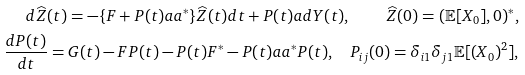<formula> <loc_0><loc_0><loc_500><loc_500>d \widehat { Z } ( t ) = - \{ F + P ( t ) a a ^ { * } \} \widehat { Z } ( t ) d t + P ( t ) a d Y ( t ) , \quad \widehat { Z } ( 0 ) = ( \mathbb { E } [ X _ { 0 } ] , 0 ) ^ { * } , \\ \frac { d P ( t ) } { d t } = G ( t ) - F P ( t ) - P ( t ) F ^ { * } - P ( t ) a a ^ { * } P ( t ) , \quad P _ { i j } ( 0 ) = \delta _ { i 1 } \delta _ { j 1 } \mathbb { E } [ ( X _ { 0 } ) ^ { 2 } ] ,</formula> 